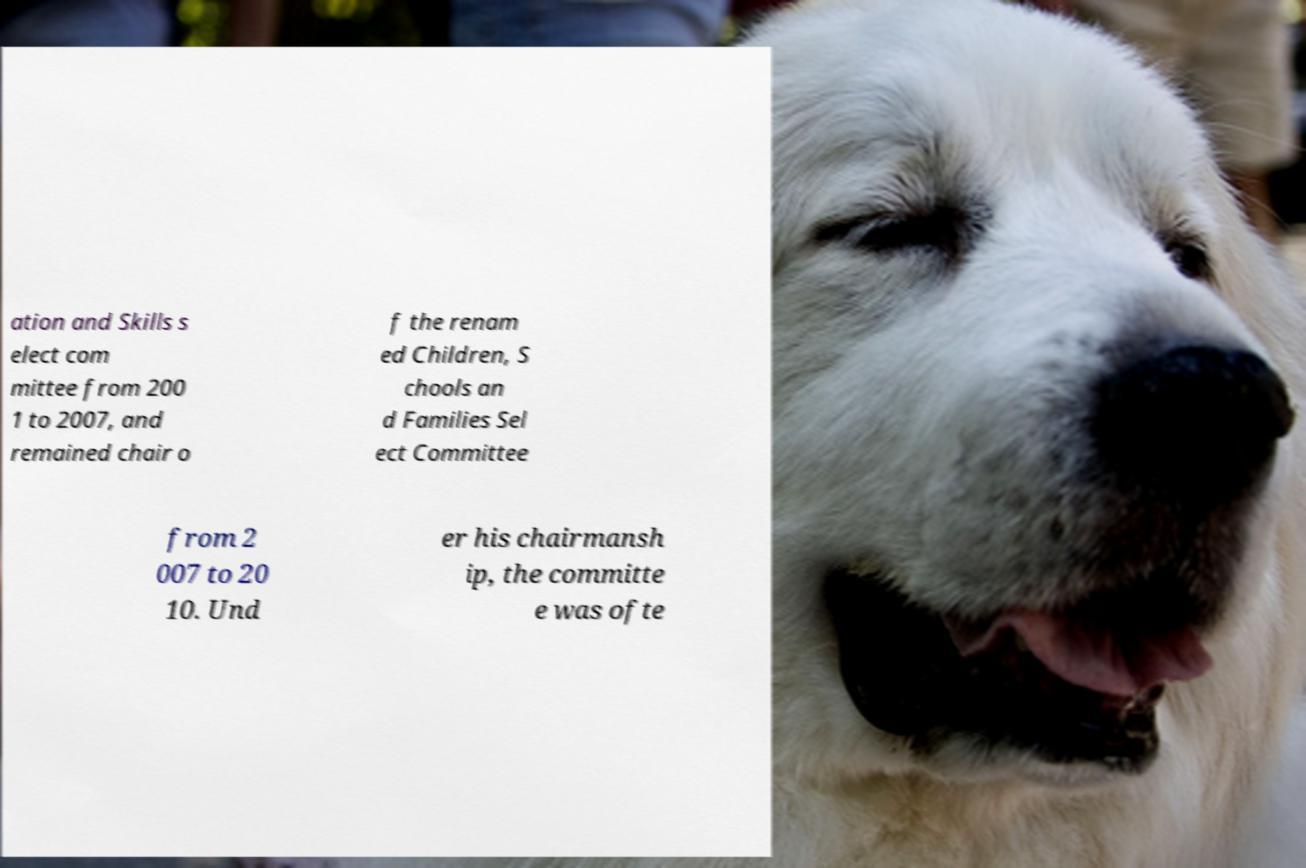Please read and relay the text visible in this image. What does it say? ation and Skills s elect com mittee from 200 1 to 2007, and remained chair o f the renam ed Children, S chools an d Families Sel ect Committee from 2 007 to 20 10. Und er his chairmansh ip, the committe e was ofte 